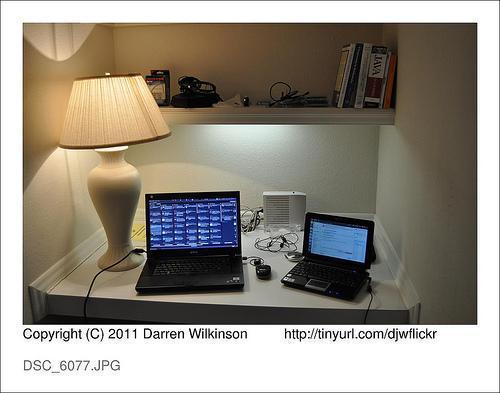How many laptops are there?
Give a very brief answer. 2. How many lamps are there?
Give a very brief answer. 1. 